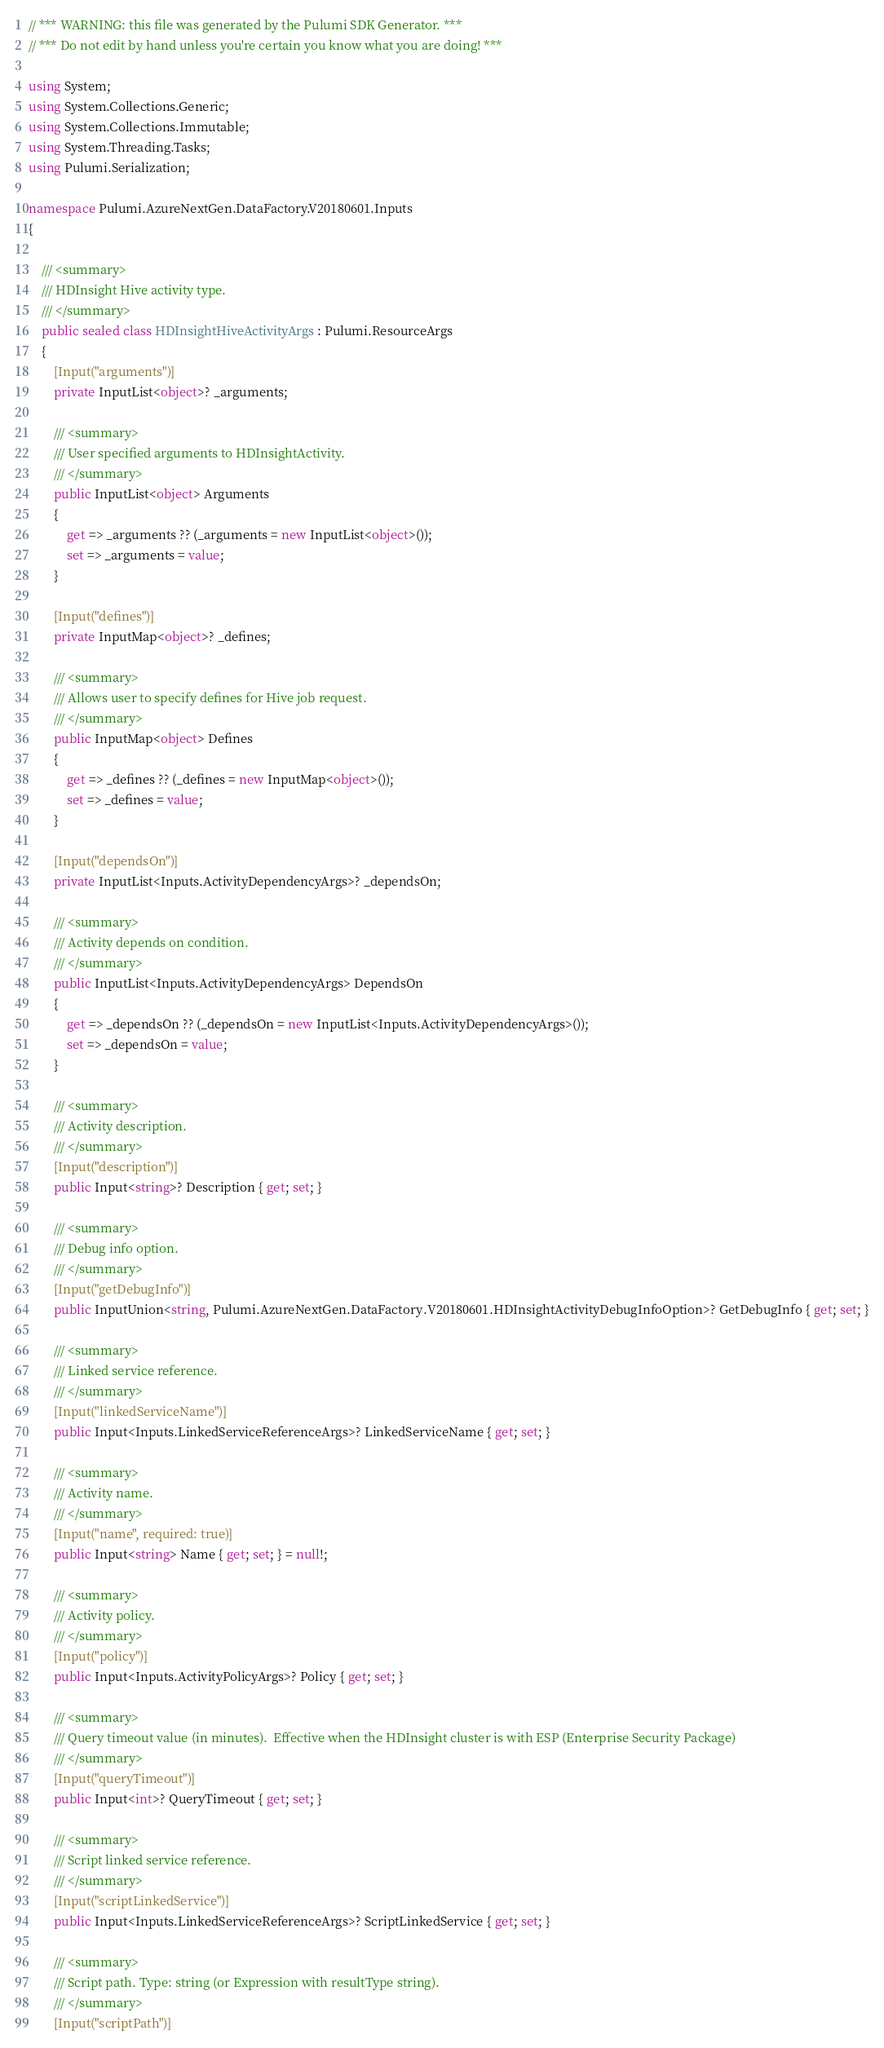<code> <loc_0><loc_0><loc_500><loc_500><_C#_>// *** WARNING: this file was generated by the Pulumi SDK Generator. ***
// *** Do not edit by hand unless you're certain you know what you are doing! ***

using System;
using System.Collections.Generic;
using System.Collections.Immutable;
using System.Threading.Tasks;
using Pulumi.Serialization;

namespace Pulumi.AzureNextGen.DataFactory.V20180601.Inputs
{

    /// <summary>
    /// HDInsight Hive activity type.
    /// </summary>
    public sealed class HDInsightHiveActivityArgs : Pulumi.ResourceArgs
    {
        [Input("arguments")]
        private InputList<object>? _arguments;

        /// <summary>
        /// User specified arguments to HDInsightActivity.
        /// </summary>
        public InputList<object> Arguments
        {
            get => _arguments ?? (_arguments = new InputList<object>());
            set => _arguments = value;
        }

        [Input("defines")]
        private InputMap<object>? _defines;

        /// <summary>
        /// Allows user to specify defines for Hive job request.
        /// </summary>
        public InputMap<object> Defines
        {
            get => _defines ?? (_defines = new InputMap<object>());
            set => _defines = value;
        }

        [Input("dependsOn")]
        private InputList<Inputs.ActivityDependencyArgs>? _dependsOn;

        /// <summary>
        /// Activity depends on condition.
        /// </summary>
        public InputList<Inputs.ActivityDependencyArgs> DependsOn
        {
            get => _dependsOn ?? (_dependsOn = new InputList<Inputs.ActivityDependencyArgs>());
            set => _dependsOn = value;
        }

        /// <summary>
        /// Activity description.
        /// </summary>
        [Input("description")]
        public Input<string>? Description { get; set; }

        /// <summary>
        /// Debug info option.
        /// </summary>
        [Input("getDebugInfo")]
        public InputUnion<string, Pulumi.AzureNextGen.DataFactory.V20180601.HDInsightActivityDebugInfoOption>? GetDebugInfo { get; set; }

        /// <summary>
        /// Linked service reference.
        /// </summary>
        [Input("linkedServiceName")]
        public Input<Inputs.LinkedServiceReferenceArgs>? LinkedServiceName { get; set; }

        /// <summary>
        /// Activity name.
        /// </summary>
        [Input("name", required: true)]
        public Input<string> Name { get; set; } = null!;

        /// <summary>
        /// Activity policy.
        /// </summary>
        [Input("policy")]
        public Input<Inputs.ActivityPolicyArgs>? Policy { get; set; }

        /// <summary>
        /// Query timeout value (in minutes).  Effective when the HDInsight cluster is with ESP (Enterprise Security Package)
        /// </summary>
        [Input("queryTimeout")]
        public Input<int>? QueryTimeout { get; set; }

        /// <summary>
        /// Script linked service reference.
        /// </summary>
        [Input("scriptLinkedService")]
        public Input<Inputs.LinkedServiceReferenceArgs>? ScriptLinkedService { get; set; }

        /// <summary>
        /// Script path. Type: string (or Expression with resultType string).
        /// </summary>
        [Input("scriptPath")]</code> 